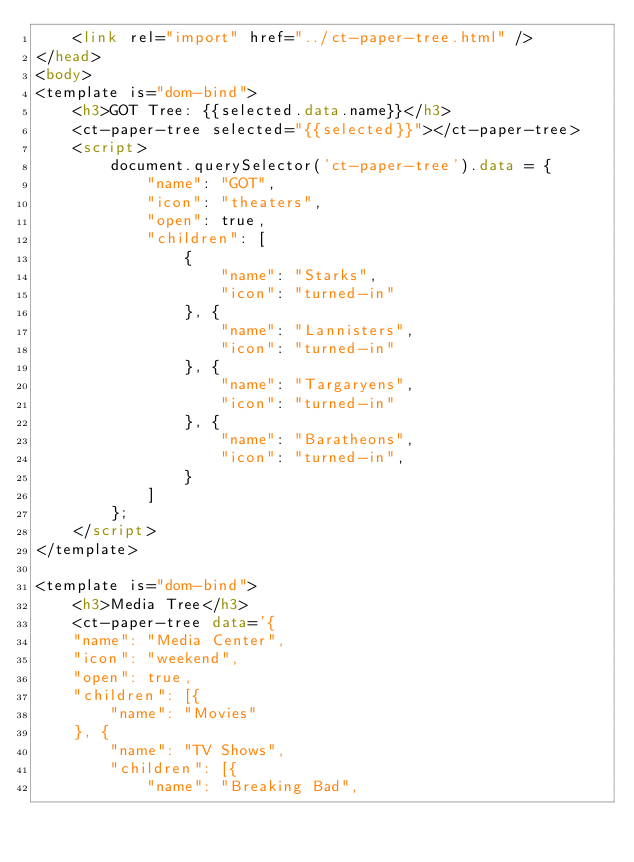Convert code to text. <code><loc_0><loc_0><loc_500><loc_500><_HTML_>    <link rel="import" href="../ct-paper-tree.html" />
</head>
<body>
<template is="dom-bind">
    <h3>GOT Tree: {{selected.data.name}}</h3>
    <ct-paper-tree selected="{{selected}}"></ct-paper-tree>
    <script>
        document.querySelector('ct-paper-tree').data = {
            "name": "GOT",
            "icon": "theaters",
            "open": true,
            "children": [
                {
                    "name": "Starks",
                    "icon": "turned-in"
                }, {
                    "name": "Lannisters",
                    "icon": "turned-in"
                }, {
                    "name": "Targaryens",
                    "icon": "turned-in"
                }, {
                    "name": "Baratheons",
                    "icon": "turned-in",
                }
            ]
        };
    </script>
</template>

<template is="dom-bind">
    <h3>Media Tree</h3>
    <ct-paper-tree data='{
    "name": "Media Center",
    "icon": "weekend",
    "open": true,
    "children": [{
        "name": "Movies"
    }, {
        "name": "TV Shows",
        "children": [{
            "name": "Breaking Bad",</code> 